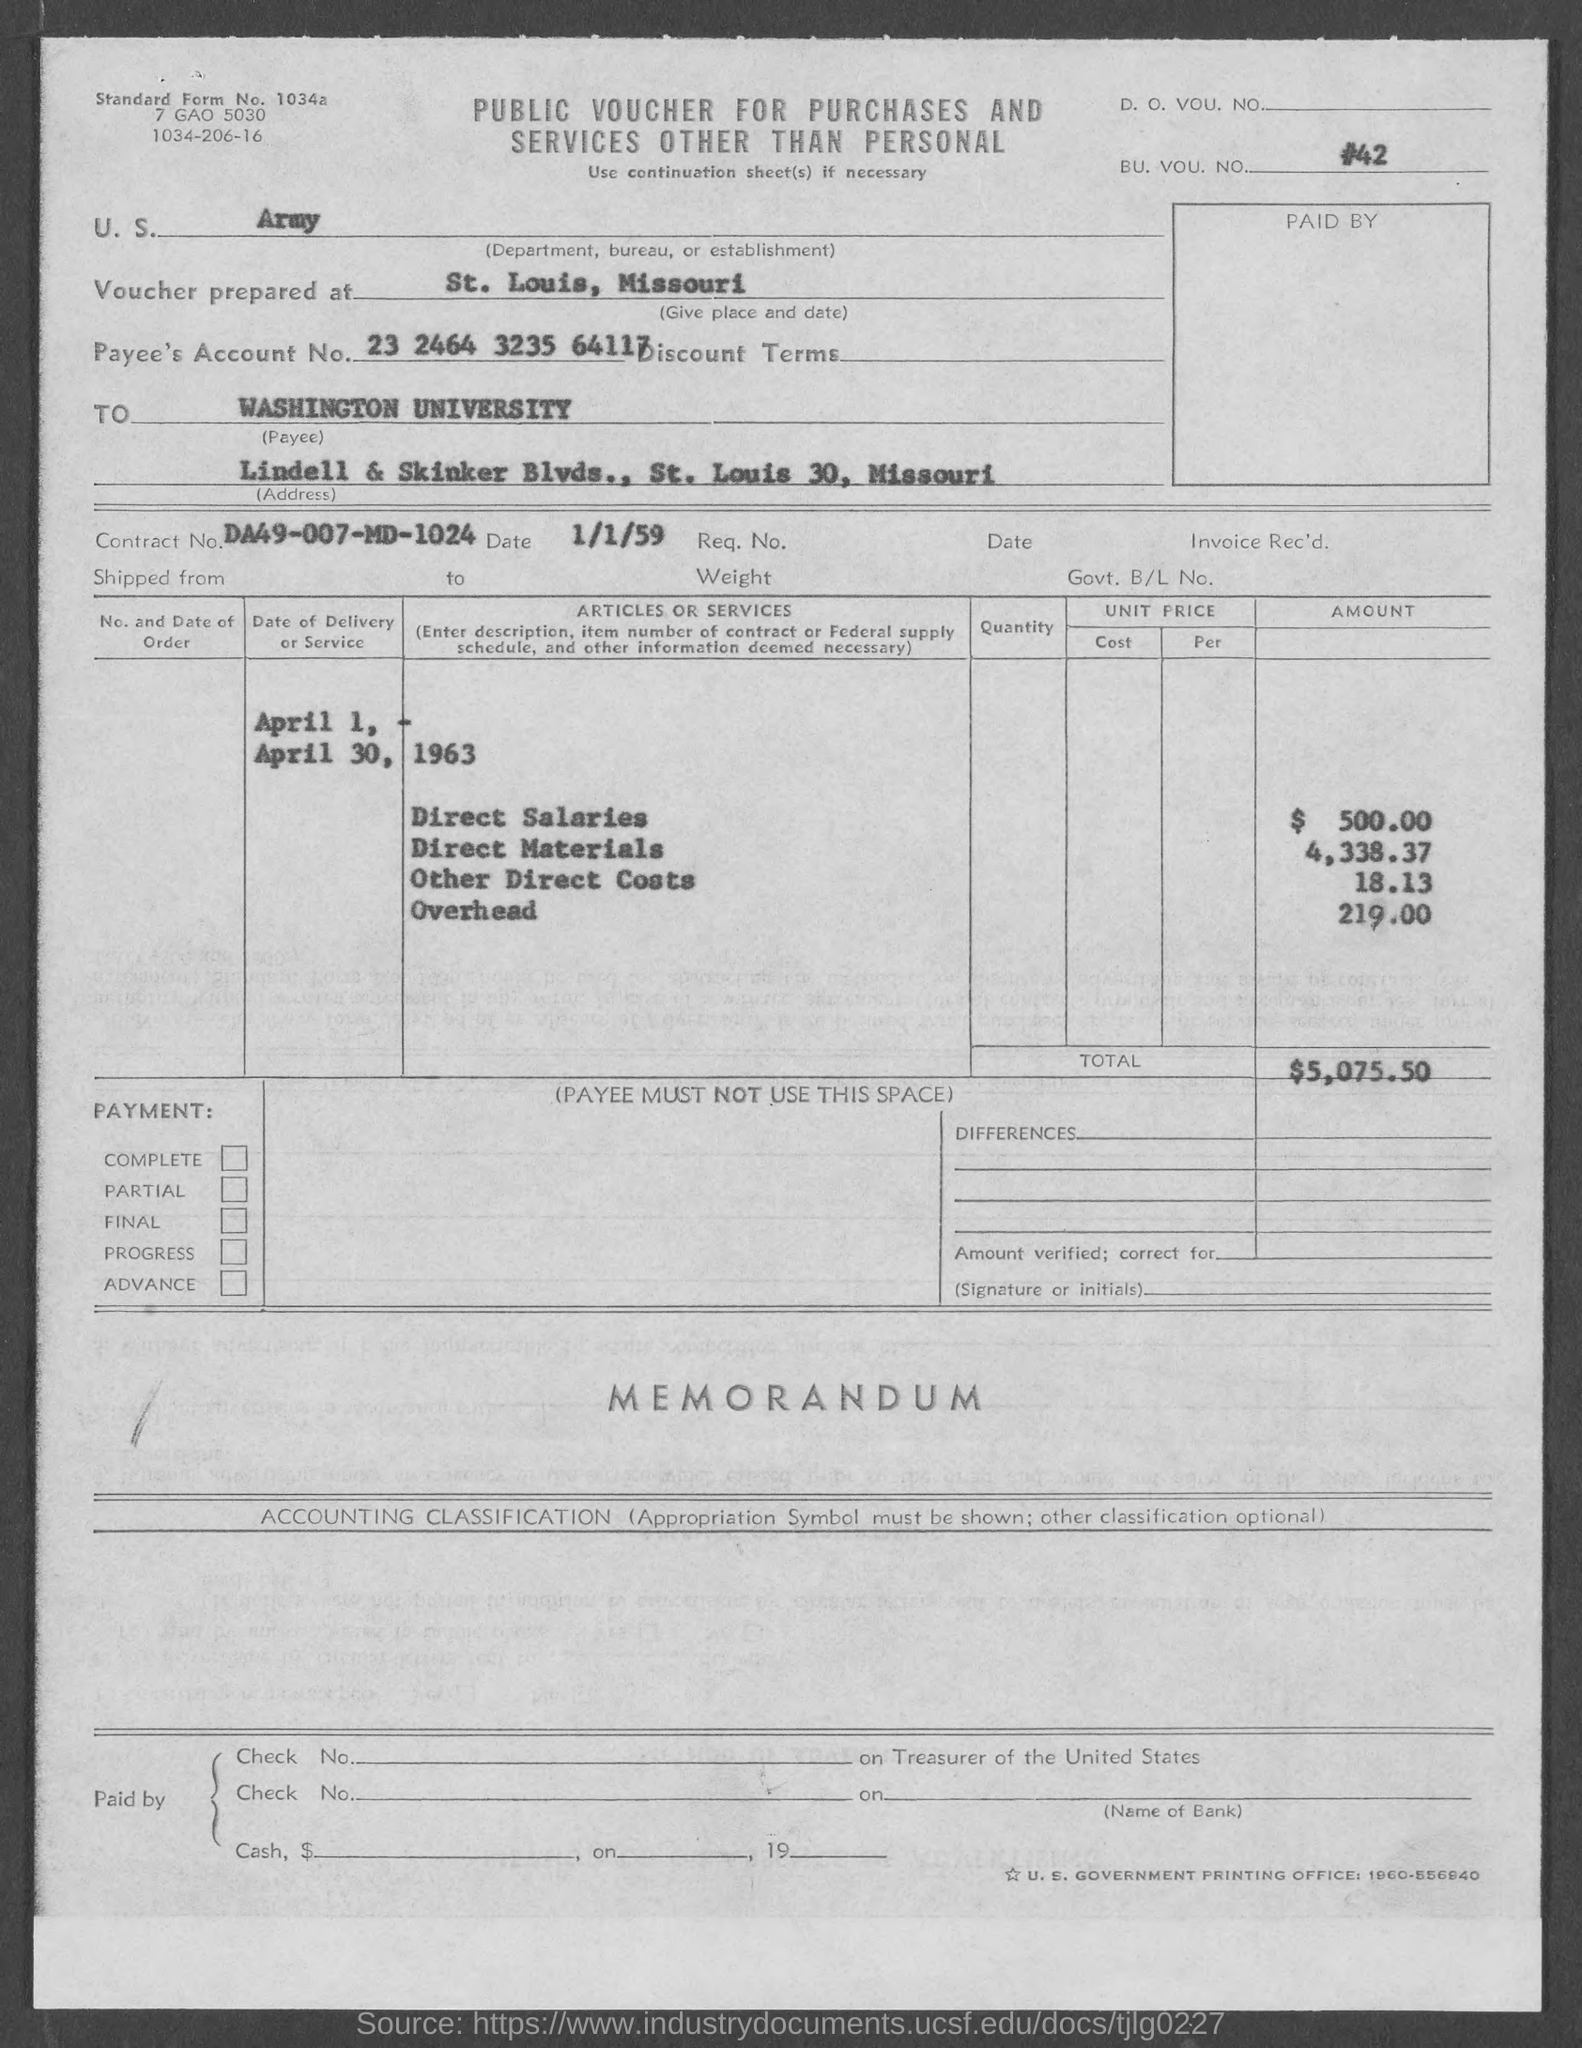What is the BU. VOU. NO. mentioned in the voucher?
Offer a terse response. #42. Where is the voucher prepared at?
Make the answer very short. St. Louis, Missouri. What is the Payee's Account No. given in the voucher?
Ensure brevity in your answer.  23 2464 3235 64117. What is the Payee's name given in the voucher?
Your answer should be very brief. WASHINGTON UNIVERSITY. What is the Contract No. given in the voucher?
Keep it short and to the point. DA49-007-MD-1024. What is the direct salaries cost mentioned in the voucher?
Your answer should be compact. $ 500.00. What is the total voucher amount mentioned in the document?
Provide a short and direct response. $5,075.50. 